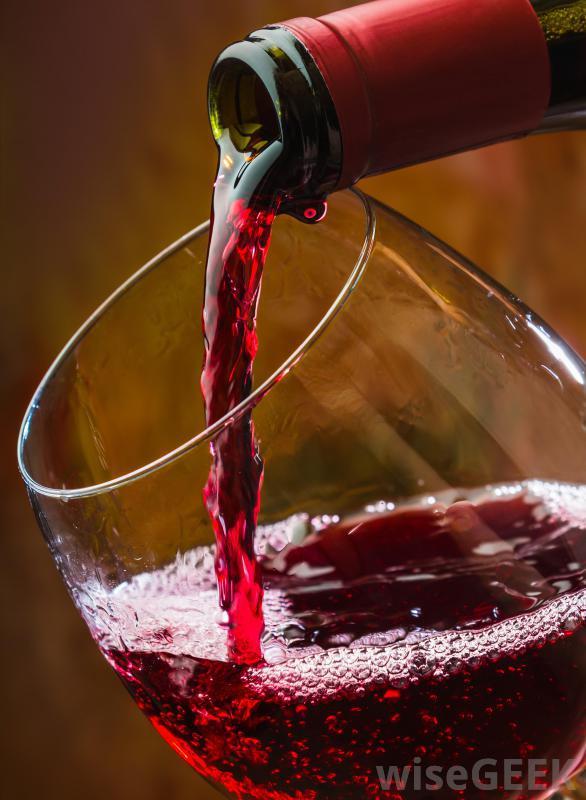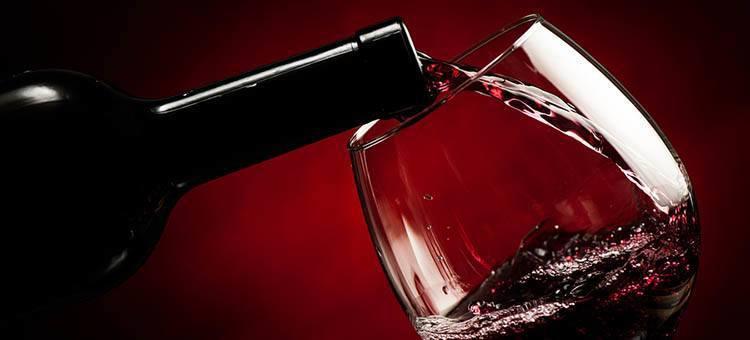The first image is the image on the left, the second image is the image on the right. Assess this claim about the two images: "There are two glasses in each of the images.". Correct or not? Answer yes or no. No. The first image is the image on the left, the second image is the image on the right. For the images shown, is this caption "The left image contains two glasses of wine." true? Answer yes or no. No. 